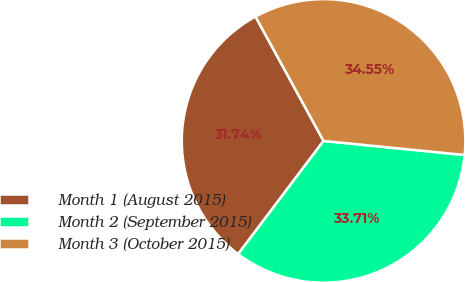Convert chart to OTSL. <chart><loc_0><loc_0><loc_500><loc_500><pie_chart><fcel>Month 1 (August 2015)<fcel>Month 2 (September 2015)<fcel>Month 3 (October 2015)<nl><fcel>31.74%<fcel>33.71%<fcel>34.55%<nl></chart> 